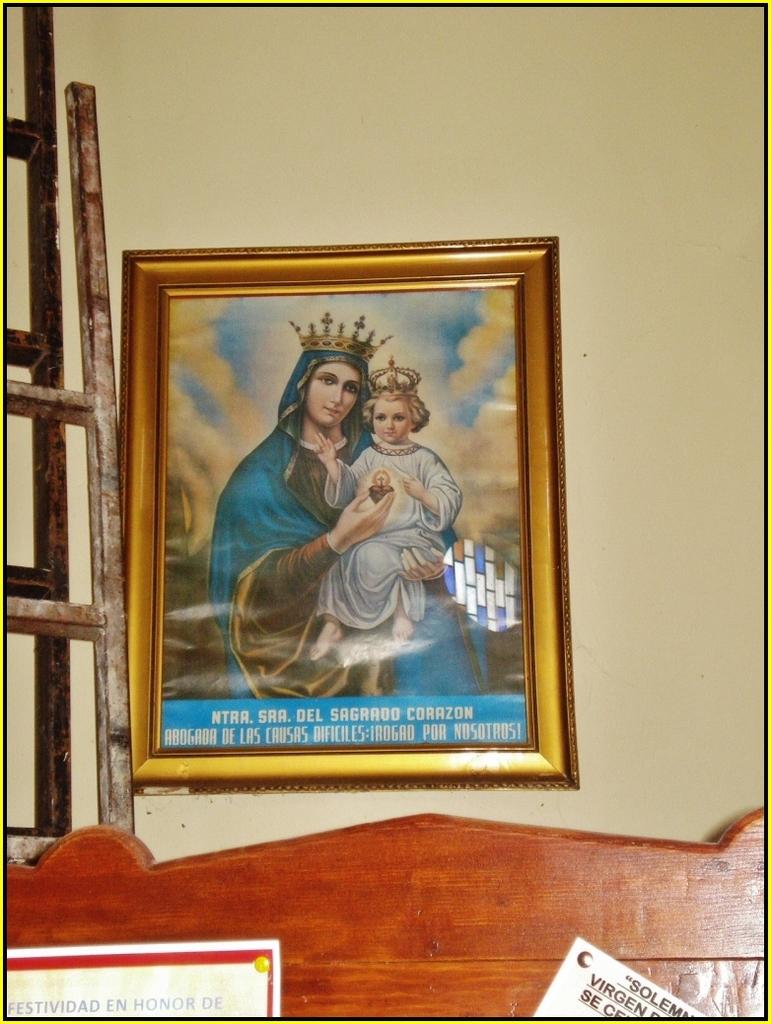What is the first word directly underneath the painting?
Offer a terse response. Ntra. 